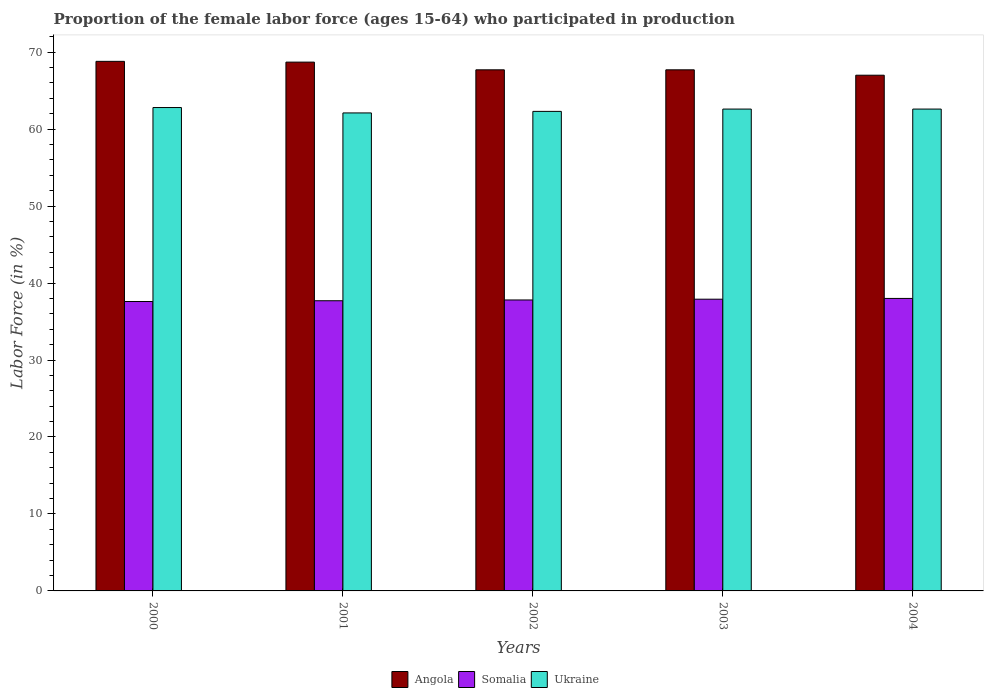How many different coloured bars are there?
Offer a very short reply. 3. Are the number of bars per tick equal to the number of legend labels?
Offer a very short reply. Yes. Are the number of bars on each tick of the X-axis equal?
Provide a short and direct response. Yes. How many bars are there on the 4th tick from the right?
Keep it short and to the point. 3. What is the proportion of the female labor force who participated in production in Angola in 2000?
Offer a terse response. 68.8. Across all years, what is the maximum proportion of the female labor force who participated in production in Somalia?
Provide a short and direct response. 38. Across all years, what is the minimum proportion of the female labor force who participated in production in Ukraine?
Provide a succinct answer. 62.1. What is the total proportion of the female labor force who participated in production in Somalia in the graph?
Provide a succinct answer. 189. What is the difference between the proportion of the female labor force who participated in production in Angola in 2001 and that in 2002?
Offer a terse response. 1. What is the difference between the proportion of the female labor force who participated in production in Ukraine in 2003 and the proportion of the female labor force who participated in production in Angola in 2001?
Your answer should be very brief. -6.1. What is the average proportion of the female labor force who participated in production in Somalia per year?
Provide a succinct answer. 37.8. In the year 2001, what is the difference between the proportion of the female labor force who participated in production in Ukraine and proportion of the female labor force who participated in production in Somalia?
Keep it short and to the point. 24.4. What is the ratio of the proportion of the female labor force who participated in production in Angola in 2003 to that in 2004?
Your answer should be very brief. 1.01. Is the difference between the proportion of the female labor force who participated in production in Ukraine in 2000 and 2002 greater than the difference between the proportion of the female labor force who participated in production in Somalia in 2000 and 2002?
Make the answer very short. Yes. What is the difference between the highest and the second highest proportion of the female labor force who participated in production in Angola?
Offer a terse response. 0.1. What is the difference between the highest and the lowest proportion of the female labor force who participated in production in Ukraine?
Give a very brief answer. 0.7. In how many years, is the proportion of the female labor force who participated in production in Somalia greater than the average proportion of the female labor force who participated in production in Somalia taken over all years?
Ensure brevity in your answer.  2. What does the 3rd bar from the left in 2002 represents?
Ensure brevity in your answer.  Ukraine. What does the 2nd bar from the right in 2001 represents?
Make the answer very short. Somalia. Is it the case that in every year, the sum of the proportion of the female labor force who participated in production in Angola and proportion of the female labor force who participated in production in Ukraine is greater than the proportion of the female labor force who participated in production in Somalia?
Offer a very short reply. Yes. How many years are there in the graph?
Give a very brief answer. 5. What is the difference between two consecutive major ticks on the Y-axis?
Give a very brief answer. 10. Are the values on the major ticks of Y-axis written in scientific E-notation?
Your response must be concise. No. Does the graph contain any zero values?
Ensure brevity in your answer.  No. Does the graph contain grids?
Make the answer very short. No. Where does the legend appear in the graph?
Keep it short and to the point. Bottom center. How are the legend labels stacked?
Make the answer very short. Horizontal. What is the title of the graph?
Give a very brief answer. Proportion of the female labor force (ages 15-64) who participated in production. Does "Mauritania" appear as one of the legend labels in the graph?
Make the answer very short. No. What is the label or title of the X-axis?
Keep it short and to the point. Years. What is the Labor Force (in %) of Angola in 2000?
Provide a succinct answer. 68.8. What is the Labor Force (in %) in Somalia in 2000?
Your answer should be compact. 37.6. What is the Labor Force (in %) of Ukraine in 2000?
Provide a succinct answer. 62.8. What is the Labor Force (in %) in Angola in 2001?
Give a very brief answer. 68.7. What is the Labor Force (in %) of Somalia in 2001?
Provide a short and direct response. 37.7. What is the Labor Force (in %) in Ukraine in 2001?
Provide a short and direct response. 62.1. What is the Labor Force (in %) of Angola in 2002?
Keep it short and to the point. 67.7. What is the Labor Force (in %) of Somalia in 2002?
Make the answer very short. 37.8. What is the Labor Force (in %) in Ukraine in 2002?
Provide a succinct answer. 62.3. What is the Labor Force (in %) in Angola in 2003?
Offer a terse response. 67.7. What is the Labor Force (in %) of Somalia in 2003?
Your answer should be very brief. 37.9. What is the Labor Force (in %) of Ukraine in 2003?
Give a very brief answer. 62.6. What is the Labor Force (in %) in Somalia in 2004?
Give a very brief answer. 38. What is the Labor Force (in %) of Ukraine in 2004?
Your answer should be very brief. 62.6. Across all years, what is the maximum Labor Force (in %) of Angola?
Make the answer very short. 68.8. Across all years, what is the maximum Labor Force (in %) of Somalia?
Ensure brevity in your answer.  38. Across all years, what is the maximum Labor Force (in %) in Ukraine?
Your answer should be very brief. 62.8. Across all years, what is the minimum Labor Force (in %) of Somalia?
Your answer should be very brief. 37.6. Across all years, what is the minimum Labor Force (in %) in Ukraine?
Your answer should be compact. 62.1. What is the total Labor Force (in %) in Angola in the graph?
Give a very brief answer. 339.9. What is the total Labor Force (in %) in Somalia in the graph?
Your response must be concise. 189. What is the total Labor Force (in %) in Ukraine in the graph?
Provide a short and direct response. 312.4. What is the difference between the Labor Force (in %) of Somalia in 2000 and that in 2002?
Give a very brief answer. -0.2. What is the difference between the Labor Force (in %) in Ukraine in 2000 and that in 2002?
Keep it short and to the point. 0.5. What is the difference between the Labor Force (in %) of Somalia in 2000 and that in 2003?
Your answer should be very brief. -0.3. What is the difference between the Labor Force (in %) of Ukraine in 2000 and that in 2003?
Make the answer very short. 0.2. What is the difference between the Labor Force (in %) of Angola in 2000 and that in 2004?
Offer a very short reply. 1.8. What is the difference between the Labor Force (in %) in Somalia in 2000 and that in 2004?
Offer a very short reply. -0.4. What is the difference between the Labor Force (in %) in Ukraine in 2000 and that in 2004?
Offer a terse response. 0.2. What is the difference between the Labor Force (in %) of Angola in 2001 and that in 2002?
Make the answer very short. 1. What is the difference between the Labor Force (in %) of Ukraine in 2001 and that in 2002?
Give a very brief answer. -0.2. What is the difference between the Labor Force (in %) of Somalia in 2001 and that in 2003?
Offer a very short reply. -0.2. What is the difference between the Labor Force (in %) in Ukraine in 2001 and that in 2003?
Offer a terse response. -0.5. What is the difference between the Labor Force (in %) in Somalia in 2001 and that in 2004?
Offer a very short reply. -0.3. What is the difference between the Labor Force (in %) in Somalia in 2002 and that in 2003?
Your response must be concise. -0.1. What is the difference between the Labor Force (in %) in Ukraine in 2002 and that in 2003?
Keep it short and to the point. -0.3. What is the difference between the Labor Force (in %) in Angola in 2003 and that in 2004?
Make the answer very short. 0.7. What is the difference between the Labor Force (in %) in Somalia in 2003 and that in 2004?
Offer a very short reply. -0.1. What is the difference between the Labor Force (in %) in Ukraine in 2003 and that in 2004?
Offer a terse response. 0. What is the difference between the Labor Force (in %) in Angola in 2000 and the Labor Force (in %) in Somalia in 2001?
Offer a very short reply. 31.1. What is the difference between the Labor Force (in %) in Angola in 2000 and the Labor Force (in %) in Ukraine in 2001?
Your answer should be compact. 6.7. What is the difference between the Labor Force (in %) in Somalia in 2000 and the Labor Force (in %) in Ukraine in 2001?
Your response must be concise. -24.5. What is the difference between the Labor Force (in %) in Angola in 2000 and the Labor Force (in %) in Ukraine in 2002?
Your answer should be compact. 6.5. What is the difference between the Labor Force (in %) of Somalia in 2000 and the Labor Force (in %) of Ukraine in 2002?
Give a very brief answer. -24.7. What is the difference between the Labor Force (in %) in Angola in 2000 and the Labor Force (in %) in Somalia in 2003?
Offer a very short reply. 30.9. What is the difference between the Labor Force (in %) in Angola in 2000 and the Labor Force (in %) in Ukraine in 2003?
Your response must be concise. 6.2. What is the difference between the Labor Force (in %) of Somalia in 2000 and the Labor Force (in %) of Ukraine in 2003?
Ensure brevity in your answer.  -25. What is the difference between the Labor Force (in %) in Angola in 2000 and the Labor Force (in %) in Somalia in 2004?
Make the answer very short. 30.8. What is the difference between the Labor Force (in %) of Angola in 2001 and the Labor Force (in %) of Somalia in 2002?
Your answer should be very brief. 30.9. What is the difference between the Labor Force (in %) of Somalia in 2001 and the Labor Force (in %) of Ukraine in 2002?
Offer a terse response. -24.6. What is the difference between the Labor Force (in %) of Angola in 2001 and the Labor Force (in %) of Somalia in 2003?
Provide a succinct answer. 30.8. What is the difference between the Labor Force (in %) of Somalia in 2001 and the Labor Force (in %) of Ukraine in 2003?
Offer a very short reply. -24.9. What is the difference between the Labor Force (in %) of Angola in 2001 and the Labor Force (in %) of Somalia in 2004?
Your answer should be very brief. 30.7. What is the difference between the Labor Force (in %) of Angola in 2001 and the Labor Force (in %) of Ukraine in 2004?
Make the answer very short. 6.1. What is the difference between the Labor Force (in %) of Somalia in 2001 and the Labor Force (in %) of Ukraine in 2004?
Keep it short and to the point. -24.9. What is the difference between the Labor Force (in %) of Angola in 2002 and the Labor Force (in %) of Somalia in 2003?
Keep it short and to the point. 29.8. What is the difference between the Labor Force (in %) in Somalia in 2002 and the Labor Force (in %) in Ukraine in 2003?
Your answer should be very brief. -24.8. What is the difference between the Labor Force (in %) in Angola in 2002 and the Labor Force (in %) in Somalia in 2004?
Ensure brevity in your answer.  29.7. What is the difference between the Labor Force (in %) in Angola in 2002 and the Labor Force (in %) in Ukraine in 2004?
Your answer should be very brief. 5.1. What is the difference between the Labor Force (in %) in Somalia in 2002 and the Labor Force (in %) in Ukraine in 2004?
Make the answer very short. -24.8. What is the difference between the Labor Force (in %) of Angola in 2003 and the Labor Force (in %) of Somalia in 2004?
Provide a short and direct response. 29.7. What is the difference between the Labor Force (in %) of Somalia in 2003 and the Labor Force (in %) of Ukraine in 2004?
Keep it short and to the point. -24.7. What is the average Labor Force (in %) in Angola per year?
Offer a terse response. 67.98. What is the average Labor Force (in %) in Somalia per year?
Provide a short and direct response. 37.8. What is the average Labor Force (in %) in Ukraine per year?
Your response must be concise. 62.48. In the year 2000, what is the difference between the Labor Force (in %) of Angola and Labor Force (in %) of Somalia?
Provide a succinct answer. 31.2. In the year 2000, what is the difference between the Labor Force (in %) in Angola and Labor Force (in %) in Ukraine?
Make the answer very short. 6. In the year 2000, what is the difference between the Labor Force (in %) of Somalia and Labor Force (in %) of Ukraine?
Make the answer very short. -25.2. In the year 2001, what is the difference between the Labor Force (in %) of Angola and Labor Force (in %) of Somalia?
Keep it short and to the point. 31. In the year 2001, what is the difference between the Labor Force (in %) in Somalia and Labor Force (in %) in Ukraine?
Make the answer very short. -24.4. In the year 2002, what is the difference between the Labor Force (in %) in Angola and Labor Force (in %) in Somalia?
Ensure brevity in your answer.  29.9. In the year 2002, what is the difference between the Labor Force (in %) in Somalia and Labor Force (in %) in Ukraine?
Give a very brief answer. -24.5. In the year 2003, what is the difference between the Labor Force (in %) of Angola and Labor Force (in %) of Somalia?
Offer a terse response. 29.8. In the year 2003, what is the difference between the Labor Force (in %) in Somalia and Labor Force (in %) in Ukraine?
Provide a succinct answer. -24.7. In the year 2004, what is the difference between the Labor Force (in %) of Angola and Labor Force (in %) of Somalia?
Keep it short and to the point. 29. In the year 2004, what is the difference between the Labor Force (in %) of Somalia and Labor Force (in %) of Ukraine?
Provide a short and direct response. -24.6. What is the ratio of the Labor Force (in %) in Angola in 2000 to that in 2001?
Offer a terse response. 1. What is the ratio of the Labor Force (in %) of Ukraine in 2000 to that in 2001?
Your answer should be very brief. 1.01. What is the ratio of the Labor Force (in %) of Angola in 2000 to that in 2002?
Make the answer very short. 1.02. What is the ratio of the Labor Force (in %) in Ukraine in 2000 to that in 2002?
Make the answer very short. 1.01. What is the ratio of the Labor Force (in %) of Angola in 2000 to that in 2003?
Your response must be concise. 1.02. What is the ratio of the Labor Force (in %) of Ukraine in 2000 to that in 2003?
Your answer should be compact. 1. What is the ratio of the Labor Force (in %) of Angola in 2000 to that in 2004?
Your answer should be compact. 1.03. What is the ratio of the Labor Force (in %) of Angola in 2001 to that in 2002?
Offer a very short reply. 1.01. What is the ratio of the Labor Force (in %) of Somalia in 2001 to that in 2002?
Keep it short and to the point. 1. What is the ratio of the Labor Force (in %) of Ukraine in 2001 to that in 2002?
Give a very brief answer. 1. What is the ratio of the Labor Force (in %) of Angola in 2001 to that in 2003?
Provide a short and direct response. 1.01. What is the ratio of the Labor Force (in %) of Somalia in 2001 to that in 2003?
Your answer should be very brief. 0.99. What is the ratio of the Labor Force (in %) in Angola in 2001 to that in 2004?
Keep it short and to the point. 1.03. What is the ratio of the Labor Force (in %) in Ukraine in 2001 to that in 2004?
Your response must be concise. 0.99. What is the ratio of the Labor Force (in %) in Angola in 2002 to that in 2003?
Offer a terse response. 1. What is the ratio of the Labor Force (in %) of Angola in 2002 to that in 2004?
Your answer should be compact. 1.01. What is the ratio of the Labor Force (in %) of Somalia in 2002 to that in 2004?
Offer a terse response. 0.99. What is the ratio of the Labor Force (in %) of Angola in 2003 to that in 2004?
Your answer should be compact. 1.01. What is the difference between the highest and the second highest Labor Force (in %) in Angola?
Give a very brief answer. 0.1. What is the difference between the highest and the lowest Labor Force (in %) of Somalia?
Offer a very short reply. 0.4. What is the difference between the highest and the lowest Labor Force (in %) in Ukraine?
Provide a short and direct response. 0.7. 